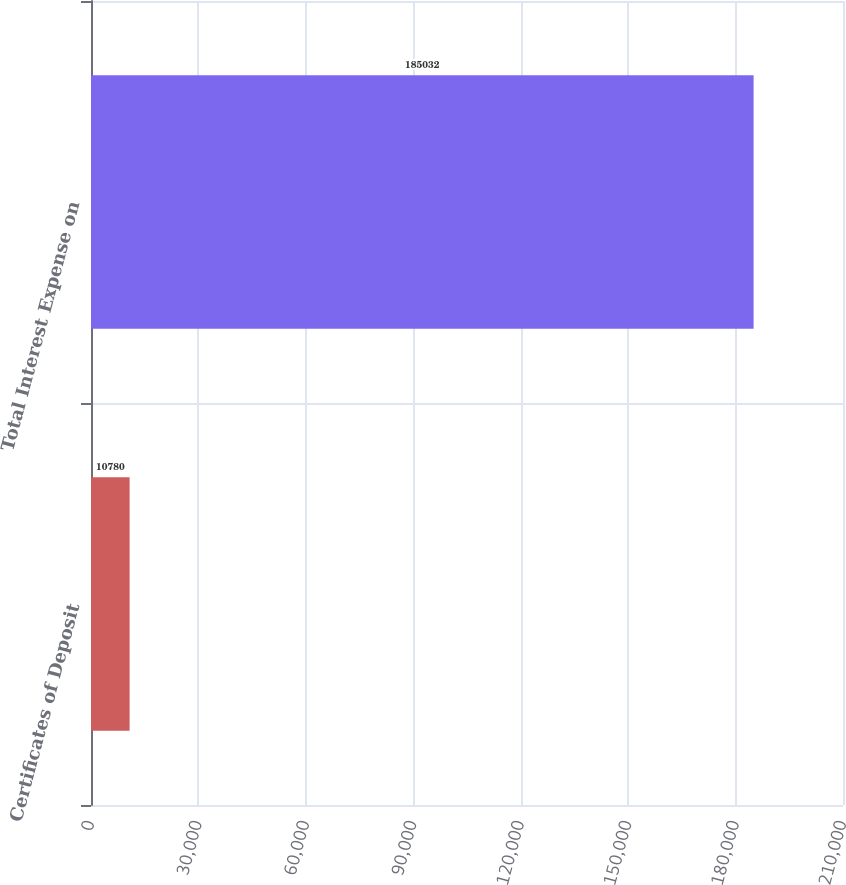Convert chart. <chart><loc_0><loc_0><loc_500><loc_500><bar_chart><fcel>Certificates of Deposit<fcel>Total Interest Expense on<nl><fcel>10780<fcel>185032<nl></chart> 